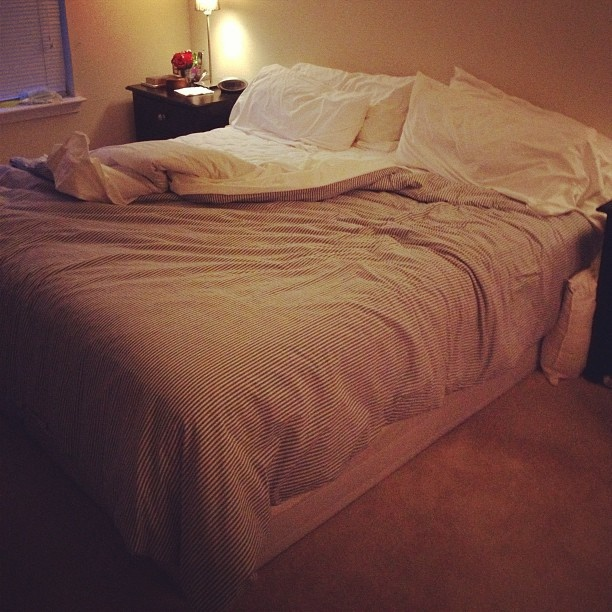Describe the objects in this image and their specific colors. I can see bed in brown, maroon, black, and tan tones and clock in brown, maroon, black, and gray tones in this image. 